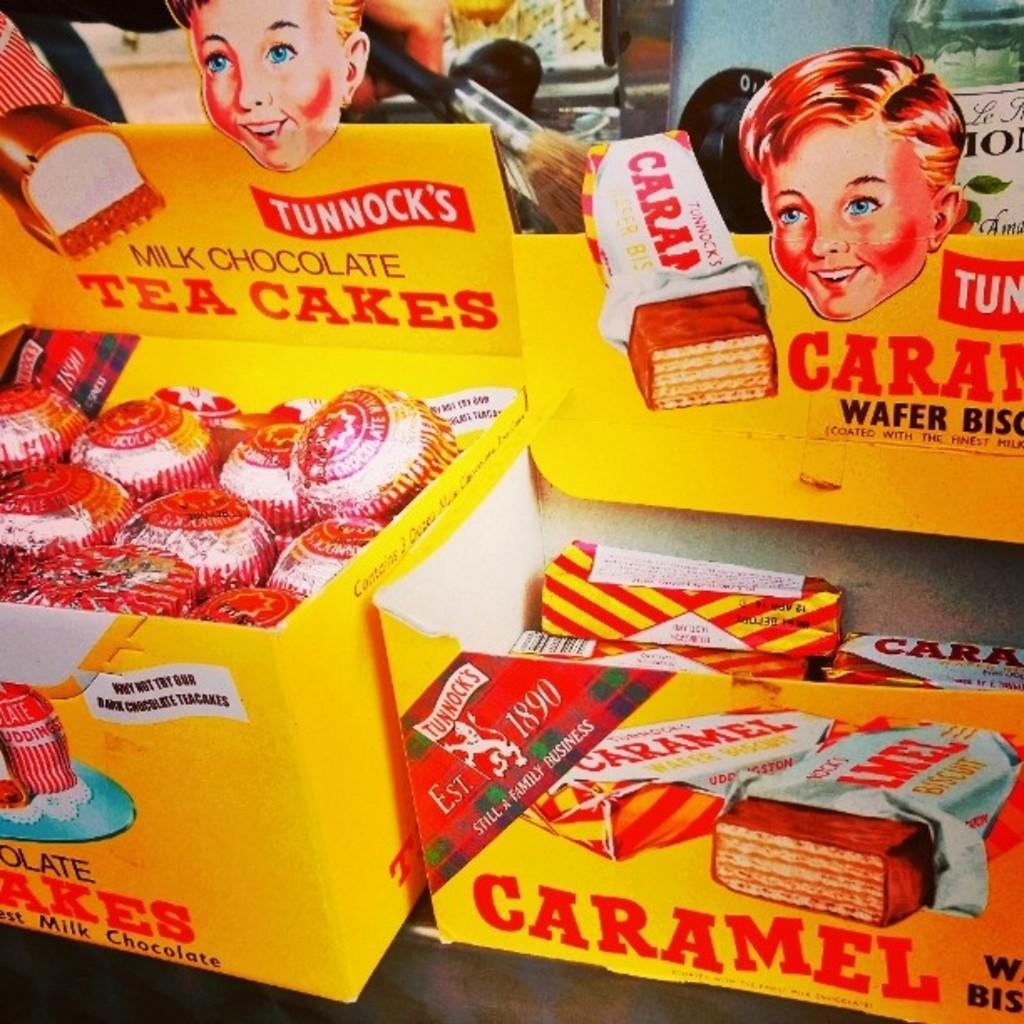Please provide a concise description of this image. This picture is mainly highlighted with the tea cakes, wafer biscuits and the boxes. 